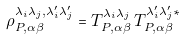Convert formula to latex. <formula><loc_0><loc_0><loc_500><loc_500>\rho ^ { \lambda _ { i } \lambda _ { j } , \lambda ^ { \prime } _ { i } \lambda ^ { \prime } _ { j } } _ { P , \alpha \beta } = T ^ { \lambda _ { i } \lambda _ { j } } _ { P , \alpha \beta } \, T ^ { \lambda ^ { \prime } _ { i } \lambda ^ { \prime } _ { j } \ast } _ { P , \alpha \beta }</formula> 